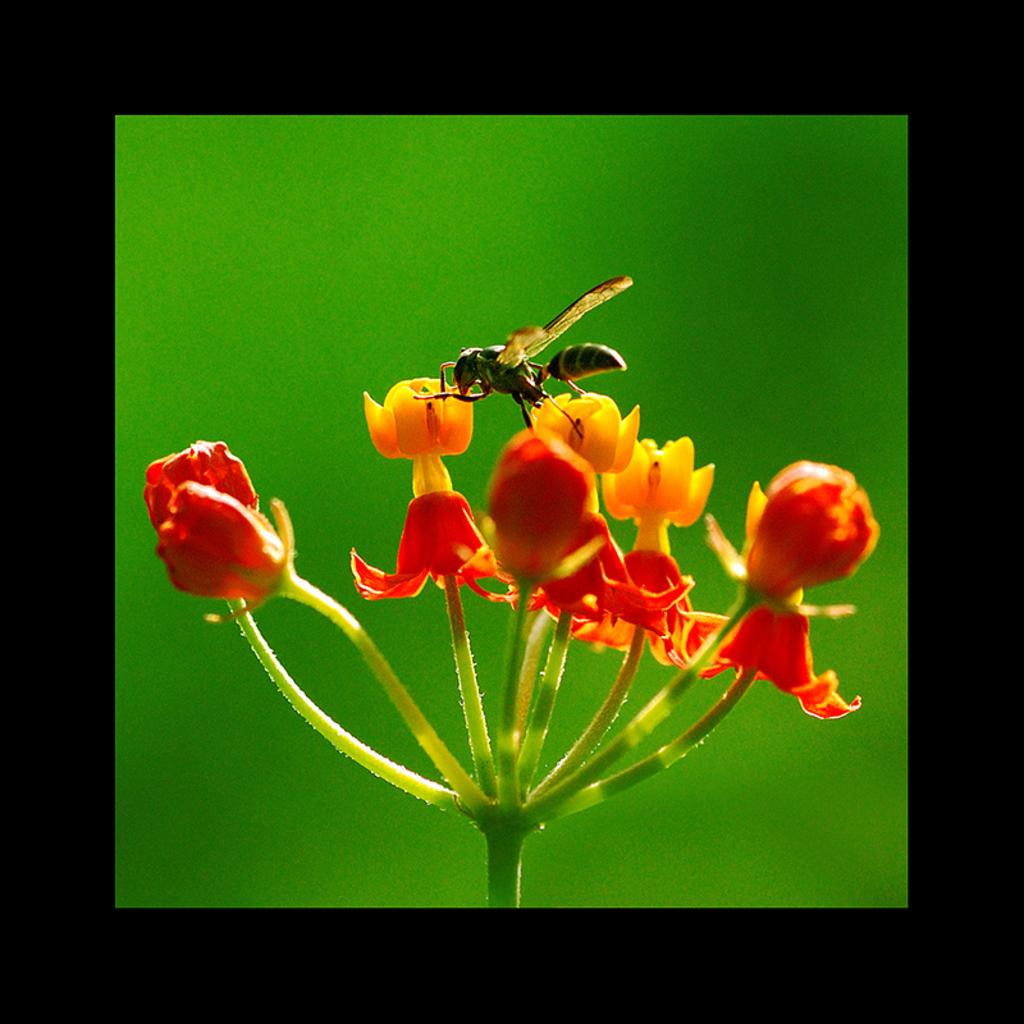What is the main subject of the image? There is an insect on a flower in the image. What color is the background of the image? The background of the image is green. Are there any distinctive features around the image? Yes, there are black borders around the image. What type of fang can be seen in the image? There is no fang present in the image; it features an insect on a flower. we describe the background color, which is green. Finally, we mention the black borders around the image as a distinctive feature. Each question is designed to elicit a specific detail about the image that is known from the provided facts. Absurd Question/Answer: What type of fang can be seen in the image? There is no fang present in the image; it features an insect on a flower. Is there an advertisement for a pan in the image? There is no advertisement or pan present in the image; it features an insect on a flower with a green background and black borders. 